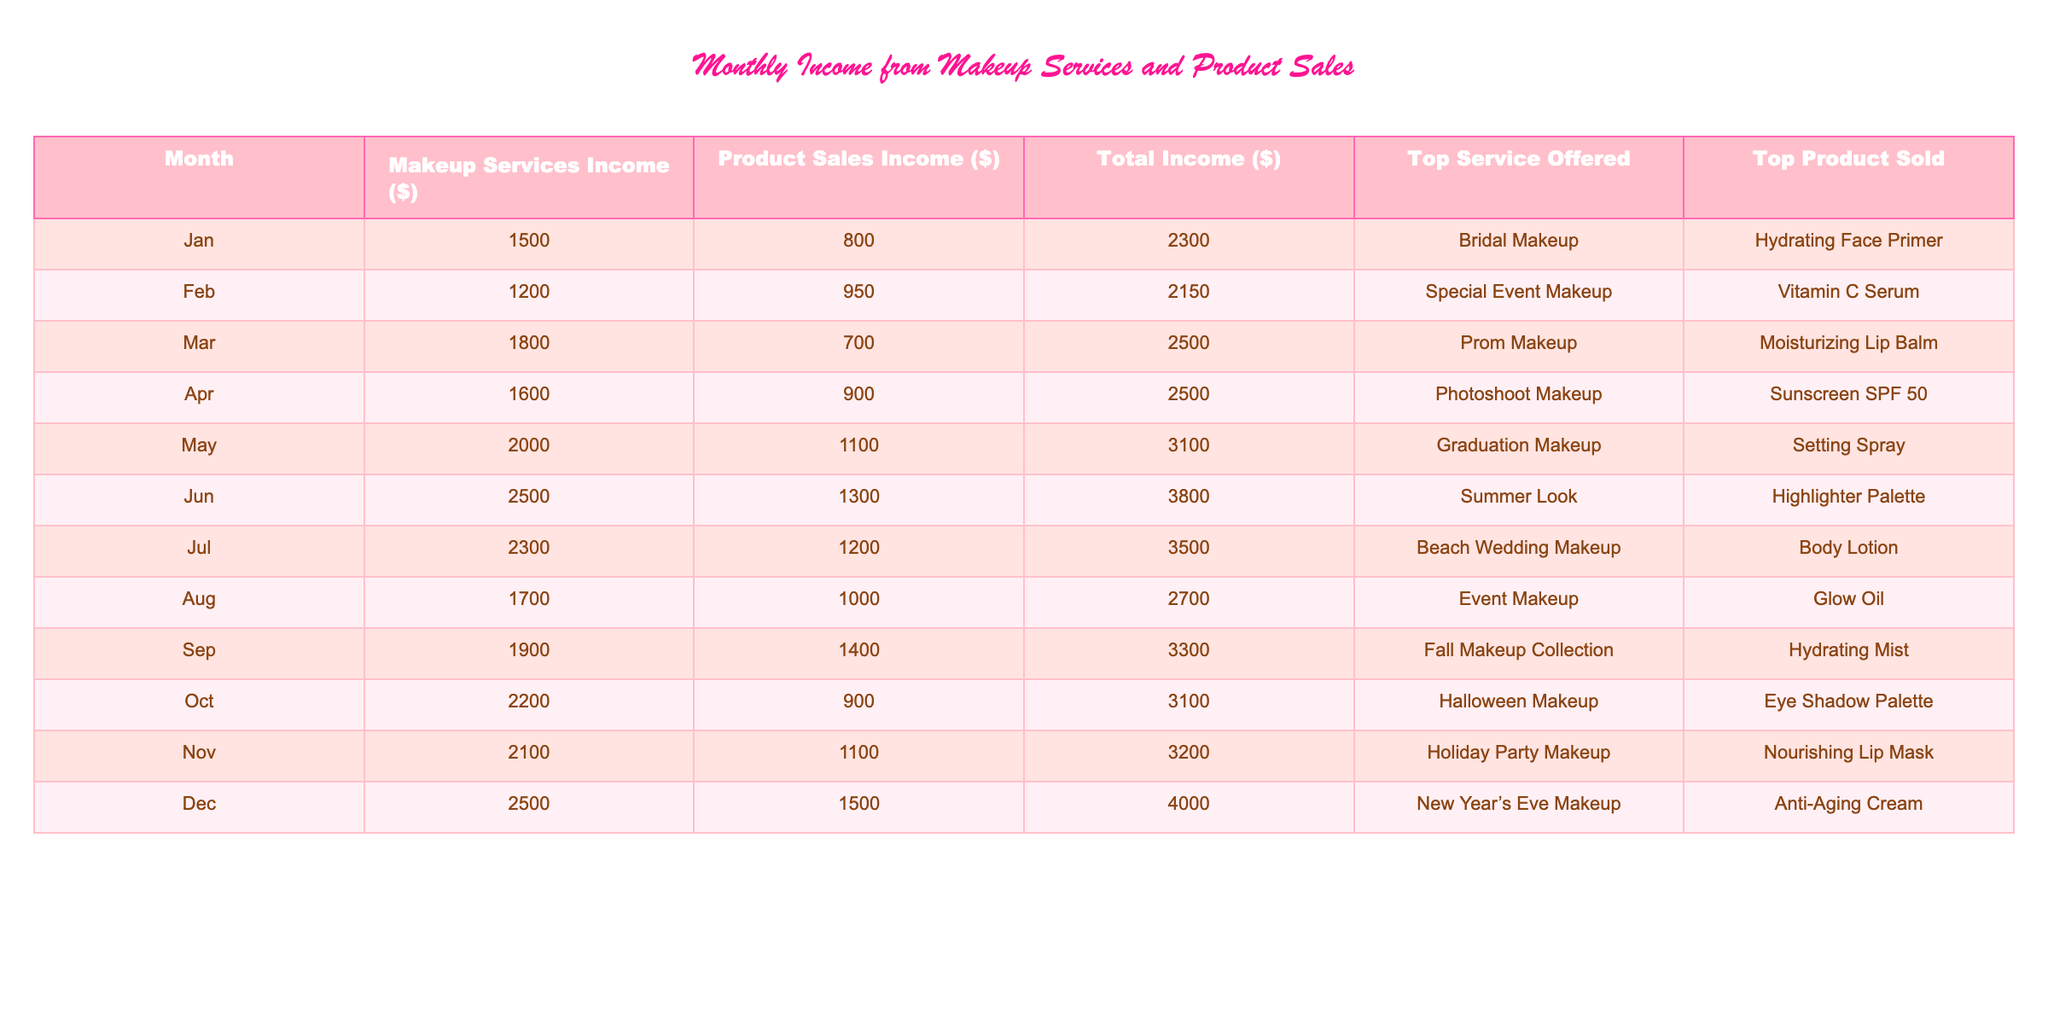What was the total income in December? The table shows that the total income for December is listed in the corresponding row, which is $4000.
Answer: 4000 Which month had the highest income from makeup services? By examining the "Makeup Services Income" column, I find that June had the highest income of $2500 for makeup services.
Answer: June What is the average income from product sales over the year? To find the average, I add all the product sales incomes: 800 + 950 + 700 + 900 + 1100 + 1300 + 1200 + 1000 + 1400 + 900 + 1100 + 1500 = 14550. Then, I divide by 12 (the number of months), which equals 1212.50.
Answer: 1212.50 Did the total income increase from September to October? I compare the total income for September, which is $3300, with October's total income of $3100. Since $3300 is greater than $3100, the income did not increase.
Answer: No What is the difference in total income between the highest and lowest months? The highest total income is December at $4000 and the lowest is February at $2150. The difference is $4000 - $2150 = $1850.
Answer: 1850 Which makeup service was offered most often based on the table? Each row lists the top service for each month. The service "Makeup" appears more consistently as a top service, but since each month has a unique top service, they are all different.
Answer: No specific service What percentage of total income came from product sales in November? The total income in November is $3200, and the product sales income is $1100. To find the percentage, I calculate (1100 / 3200) * 100 = 34.375%.
Answer: 34.38% What trend can be observed in the total income from January to December? Reviewing the "Total Income" column from January ($2300) to December ($4000), there’s a general upward trend indicating growth throughout the year.
Answer: Upward trend Which product was the top seller in March? In the row for March, the top product sold is listed as "Moisturizing Lip Balm."
Answer: Moisturizing Lip Balm How much more income did makeup services generate in July compared to April? Makeup services income in July is $2300, and in April it's $1600. The difference is $2300 - $1600 = $700.
Answer: 700 